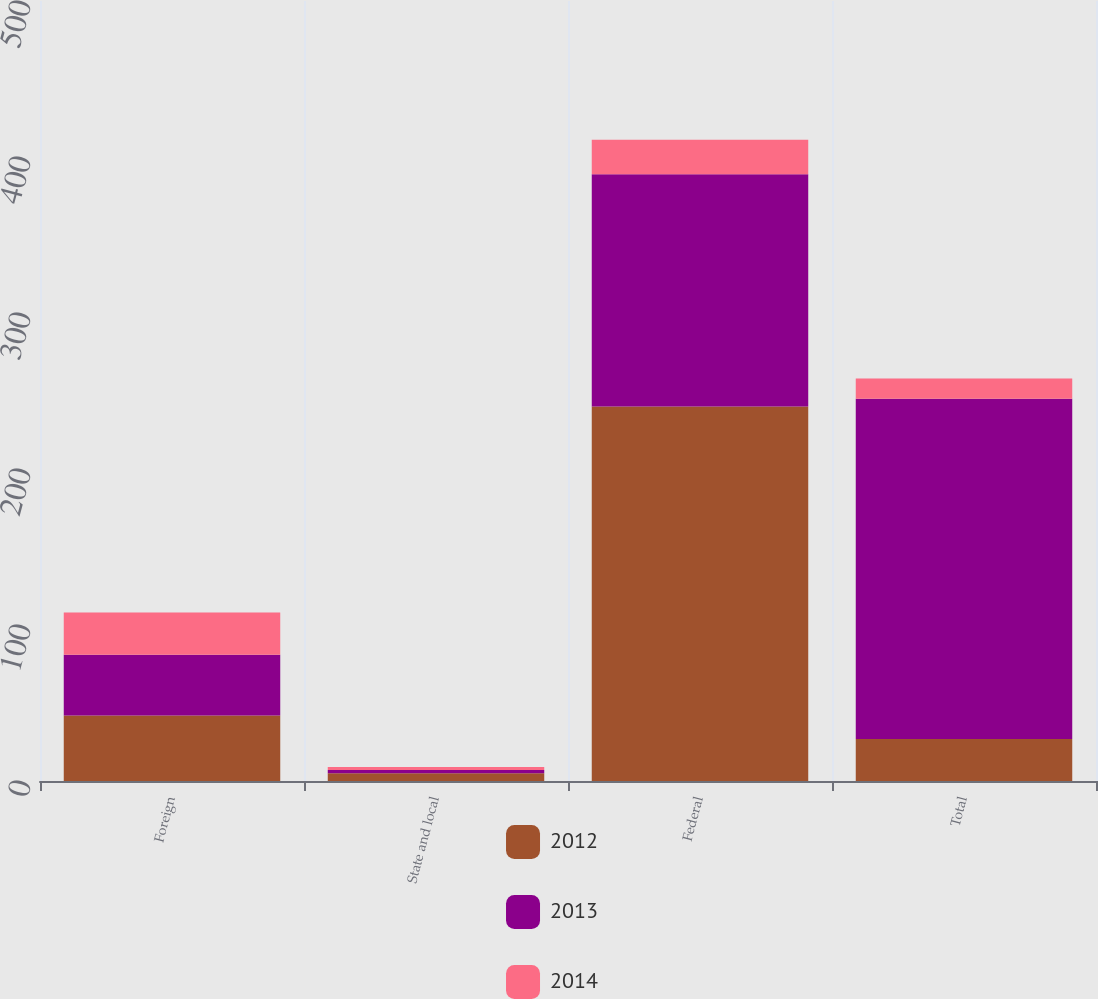<chart> <loc_0><loc_0><loc_500><loc_500><stacked_bar_chart><ecel><fcel>Foreign<fcel>State and local<fcel>Federal<fcel>Total<nl><fcel>2012<fcel>42<fcel>5<fcel>240<fcel>27<nl><fcel>2013<fcel>39<fcel>2<fcel>149<fcel>218<nl><fcel>2014<fcel>27<fcel>2<fcel>22<fcel>13<nl></chart> 